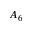Convert formula to latex. <formula><loc_0><loc_0><loc_500><loc_500>A _ { 6 }</formula> 